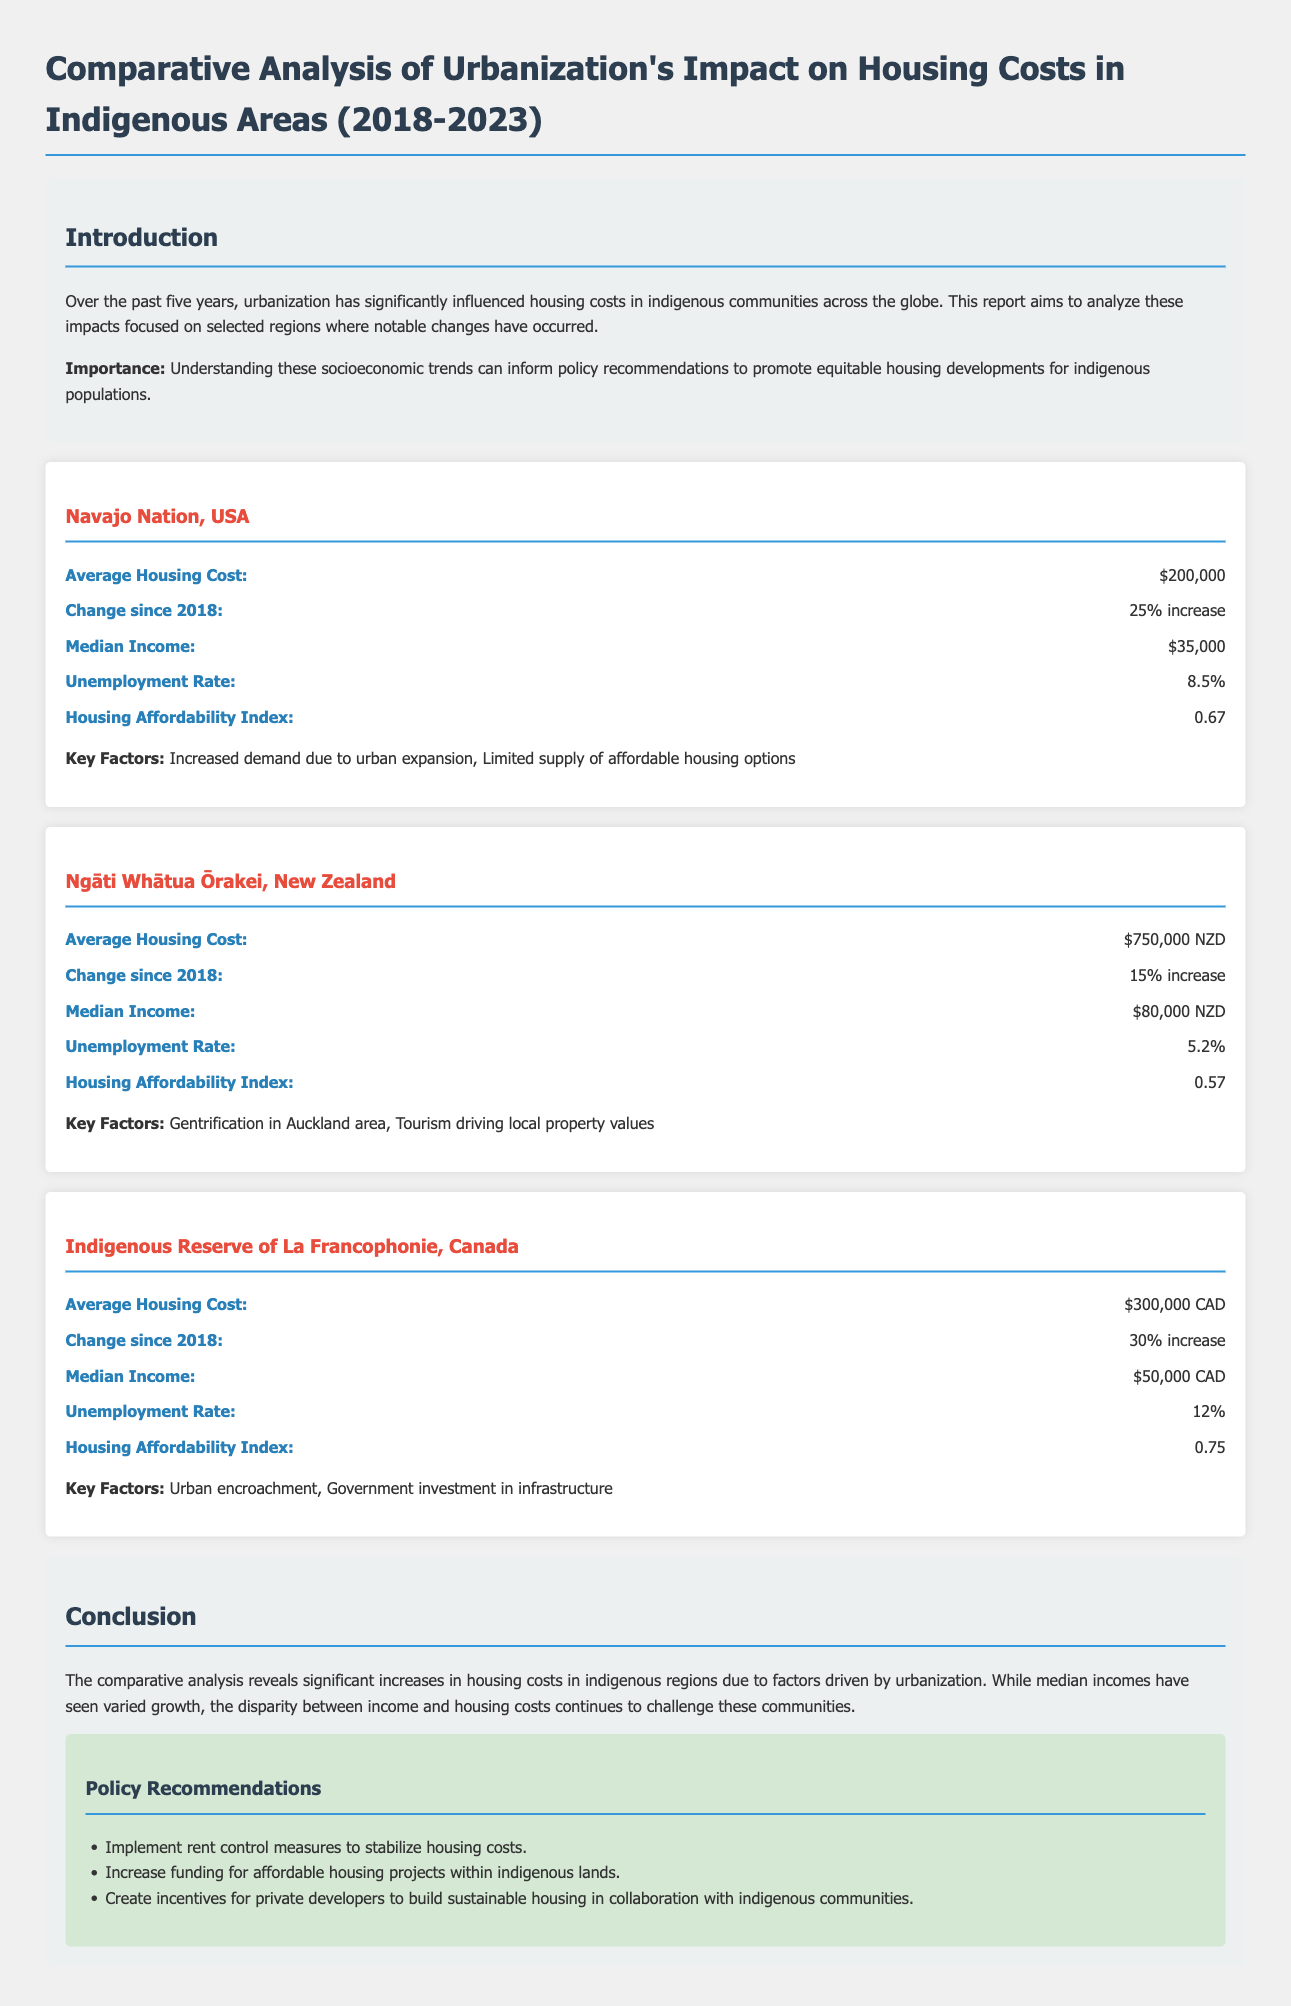What is the average housing cost in the Navajo Nation? The average housing cost in the Navajo Nation is provided in the document as $200,000.
Answer: $200,000 What was the change in housing costs in Ngāti Whātua Ōrakei since 2018? The document states there has been a 15% increase in housing costs in Ngāti Whātua Ōrakei since 2018.
Answer: 15% increase What is the median income in the Indigenous Reserve of La Francophonie? The document notes that the median income in the Indigenous Reserve of La Francophonie is $50,000 CAD.
Answer: $50,000 CAD Which region has the highest unemployment rate? By comparing the unemployment rates provided, the Indigenous Reserve of La Francophonie has the highest rate at 12%.
Answer: 12% What are the key factors affecting housing costs in the Navajo Nation? The document lists increased demand due to urban expansion and limited supply of affordable housing options as key factors.
Answer: Increased demand due to urban expansion, Limited supply of affordable housing options What is the Housing Affordability Index for Ngāti Whātua Ōrakei? The document specifies that the Housing Affordability Index for Ngāti Whātua Ōrakei is 0.57.
Answer: 0.57 What is one policy recommendation made in the report? The report recommends implementing rent control measures to stabilize housing costs as one of its policy recommendations.
Answer: Implement rent control measures to stabilize housing costs How many years does the report cover? The analysis in the document covers a span from 2018 to 2023, which is five years in total.
Answer: Five years What is the average housing cost in the Indigenous Reserve of La Francophonie? According to the document, the average housing cost in the Indigenous Reserve of La Francophonie is $300,000 CAD.
Answer: $300,000 CAD 